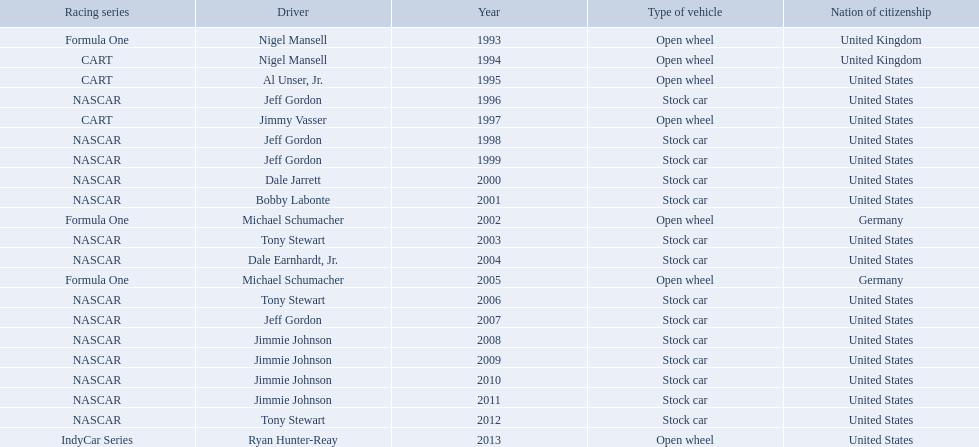What year(s) did nigel mansel receive epsy awards? 1993, 1994. What year(s) did michael schumacher receive epsy awards? 2002, 2005. What year(s) did jeff gordon receive epsy awards? 1996, 1998, 1999, 2007. What year(s) did al unser jr. receive epsy awards? 1995. Which driver only received one epsy award? Al Unser, Jr. 